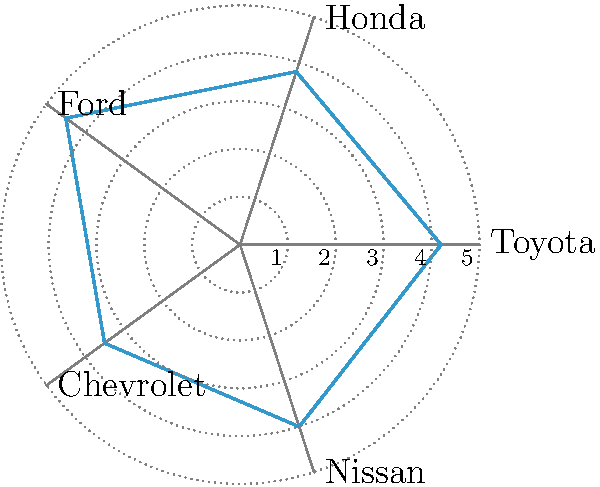As a used car dealer manager, you're analyzing customer satisfaction scores for different car brands using a radar chart. The chart shows scores for Toyota, Honda, Ford, Chevrolet, and Nissan on a scale of 1 to 5. Which brand has the highest customer satisfaction score, and what is that score? To determine the highest customer satisfaction score and the corresponding brand, we need to analyze the radar chart:

1. Identify the scale: The chart shows scores from 1 to 5, with 5 being the highest possible score.

2. Analyze each brand's position:
   - Toyota: Extends to about 4.2 on the scale
   - Honda: Extends to about 3.8 on the scale
   - Ford: Extends to about 4.5 on the scale
   - Chevrolet: Extends to about 3.5 on the scale
   - Nissan: Extends to about 4.0 on the scale

3. Compare the scores:
   Ford has the highest extension on the chart, reaching approximately 4.5 on the scale.

4. Confirm the highest score:
   Ford's score of 4.5 is the highest among all brands shown in the radar chart.

Therefore, Ford has the highest customer satisfaction score of 4.5 out of 5.
Answer: Ford, 4.5 